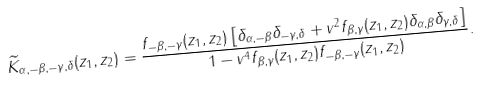Convert formula to latex. <formula><loc_0><loc_0><loc_500><loc_500>\widetilde { K } _ { \alpha , - \beta , - \gamma , \delta } ( z _ { 1 } , z _ { 2 } ) = \frac { f _ { - \beta , - \gamma } ( z _ { 1 } , z _ { 2 } ) \left [ \delta _ { \alpha , - \beta } \delta _ { - \gamma , \delta } + v ^ { 2 } f _ { \beta , \gamma } ( z _ { 1 } , z _ { 2 } ) \delta _ { \alpha , \beta } \delta _ { \gamma , \delta } \right ] } { 1 - v ^ { 4 } f _ { \beta , \gamma } ( z _ { 1 } , z _ { 2 } ) f _ { - \beta , - \gamma } ( z _ { 1 } , z _ { 2 } ) } .</formula> 